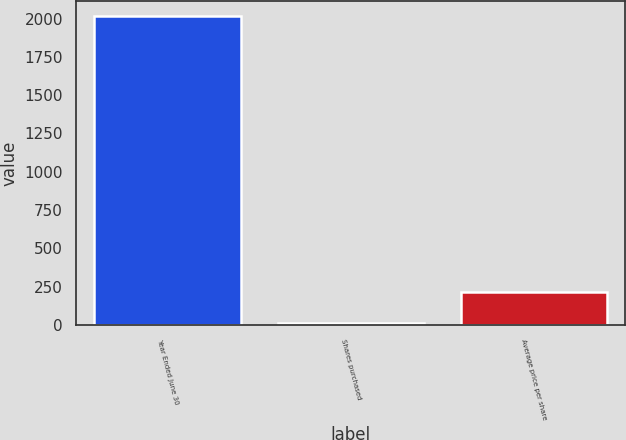<chart> <loc_0><loc_0><loc_500><loc_500><bar_chart><fcel>Year Ended June 30<fcel>Shares purchased<fcel>Average price per share<nl><fcel>2015<fcel>16<fcel>215.9<nl></chart> 